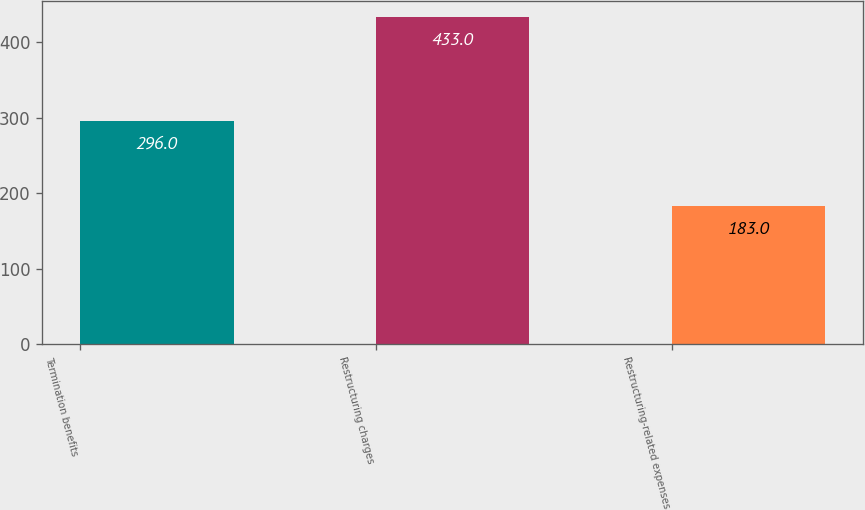Convert chart. <chart><loc_0><loc_0><loc_500><loc_500><bar_chart><fcel>Termination benefits<fcel>Restructuring charges<fcel>Restructuring-related expenses<nl><fcel>296<fcel>433<fcel>183<nl></chart> 